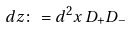<formula> <loc_0><loc_0><loc_500><loc_500>d z \colon = d ^ { 2 } x \, D _ { + } D _ { - }</formula> 